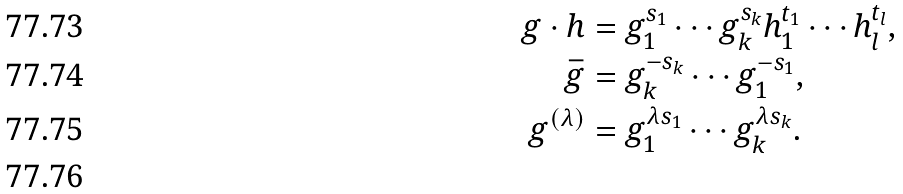<formula> <loc_0><loc_0><loc_500><loc_500>g \cdot h & = g _ { 1 } ^ { s _ { 1 } } \cdots g _ { k } ^ { s _ { k } } h _ { 1 } ^ { t _ { 1 } } \cdots h _ { l } ^ { t _ { l } } , \\ \bar { g } & = g _ { k } ^ { - s _ { k } } \cdots g _ { 1 } ^ { - s _ { 1 } } , \\ g ^ { ( \lambda ) } & = g _ { 1 } ^ { \lambda s _ { 1 } } \cdots g _ { k } ^ { \lambda s _ { k } } . \\</formula> 